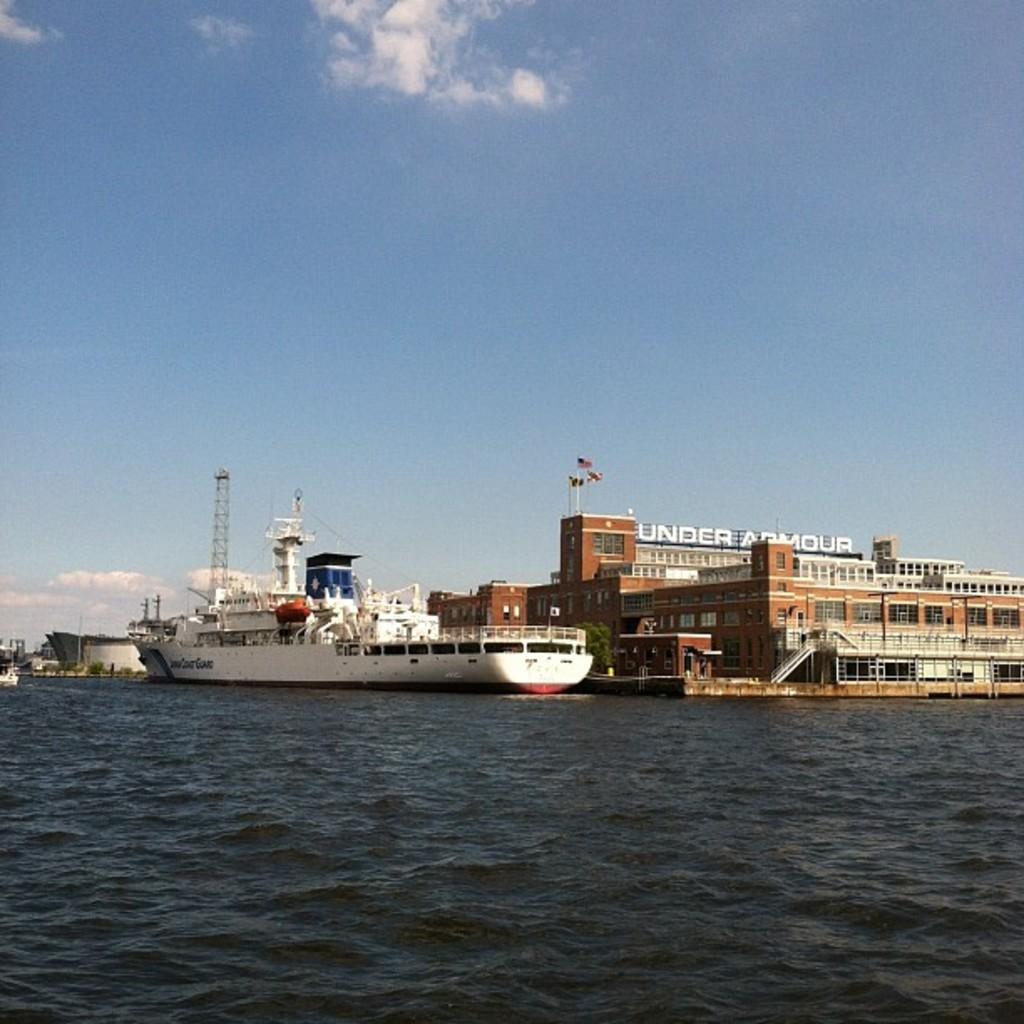How would you summarize this image in a sentence or two? In this image, I can see a ship on the water. This is the building with the windows and a name board. This looks like a tower. I think this is the sea with the water flowing. These are the clouds in the sky. 